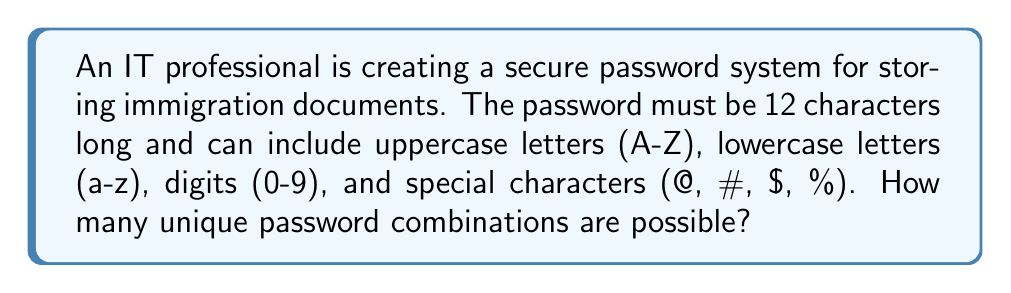Could you help me with this problem? Let's approach this step-by-step:

1. First, we need to count the number of possible characters for each position:
   - 26 uppercase letters
   - 26 lowercase letters
   - 10 digits
   - 4 special characters (@, #, $, %)
   
   Total: 26 + 26 + 10 + 4 = 66 possible characters

2. Now, for each of the 12 positions in the password, we have 66 choices.

3. According to the multiplication principle, if we have n independent events, each with m possible outcomes, the total number of possible outcomes is $m^n$.

4. In this case, we have 12 positions (n = 12), each with 66 possible characters (m = 66).

5. Therefore, the total number of possible passwords is:

   $$ 66^{12} $$

6. Calculating this:
   $$ 66^{12} = 1.39 \times 10^{22} $$

This is approximately 139 sextillion unique password combinations.
Answer: $66^{12} \approx 1.39 \times 10^{22}$ 